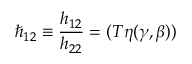Convert formula to latex. <formula><loc_0><loc_0><loc_500><loc_500>\hbar { _ } { 1 2 } \equiv \frac { h _ { 1 2 } } { h _ { 2 2 } } = ( T \eta ( \gamma , \beta ) )</formula> 